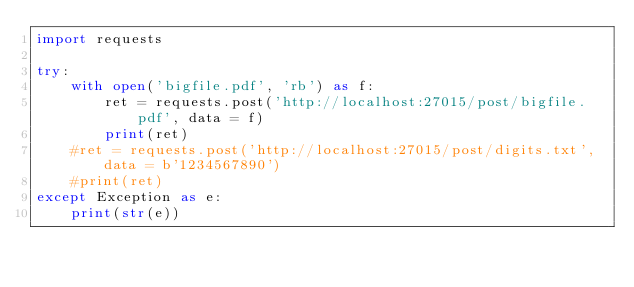Convert code to text. <code><loc_0><loc_0><loc_500><loc_500><_Python_>import requests

try:
	with open('bigfile.pdf', 'rb') as f:
		ret = requests.post('http://localhost:27015/post/bigfile.pdf', data = f)
		print(ret)
	#ret = requests.post('http://localhost:27015/post/digits.txt', data = b'1234567890')
	#print(ret)
except Exception as e:
	print(str(e))
</code> 